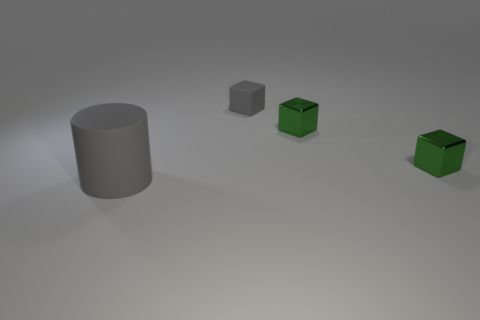Add 1 big gray rubber cylinders. How many objects exist? 5 Subtract all blocks. How many objects are left? 1 Subtract all tiny rubber objects. Subtract all metal things. How many objects are left? 1 Add 1 large gray cylinders. How many large gray cylinders are left? 2 Add 1 big gray rubber objects. How many big gray rubber objects exist? 2 Subtract 0 brown cylinders. How many objects are left? 4 